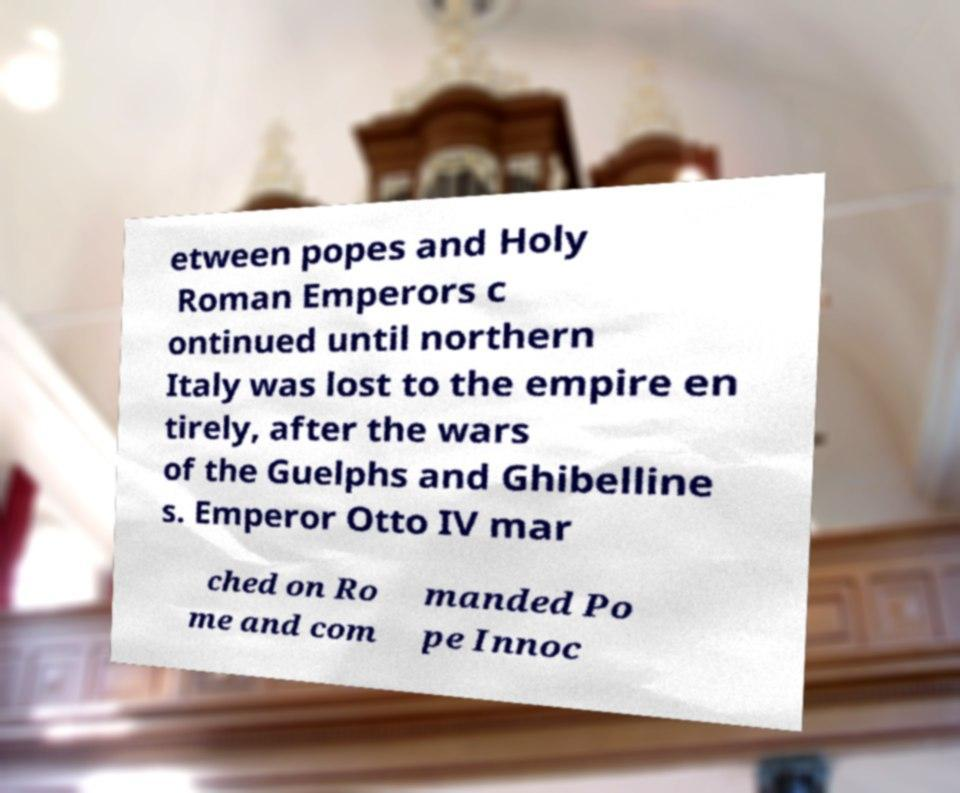For documentation purposes, I need the text within this image transcribed. Could you provide that? etween popes and Holy Roman Emperors c ontinued until northern Italy was lost to the empire en tirely, after the wars of the Guelphs and Ghibelline s. Emperor Otto IV mar ched on Ro me and com manded Po pe Innoc 